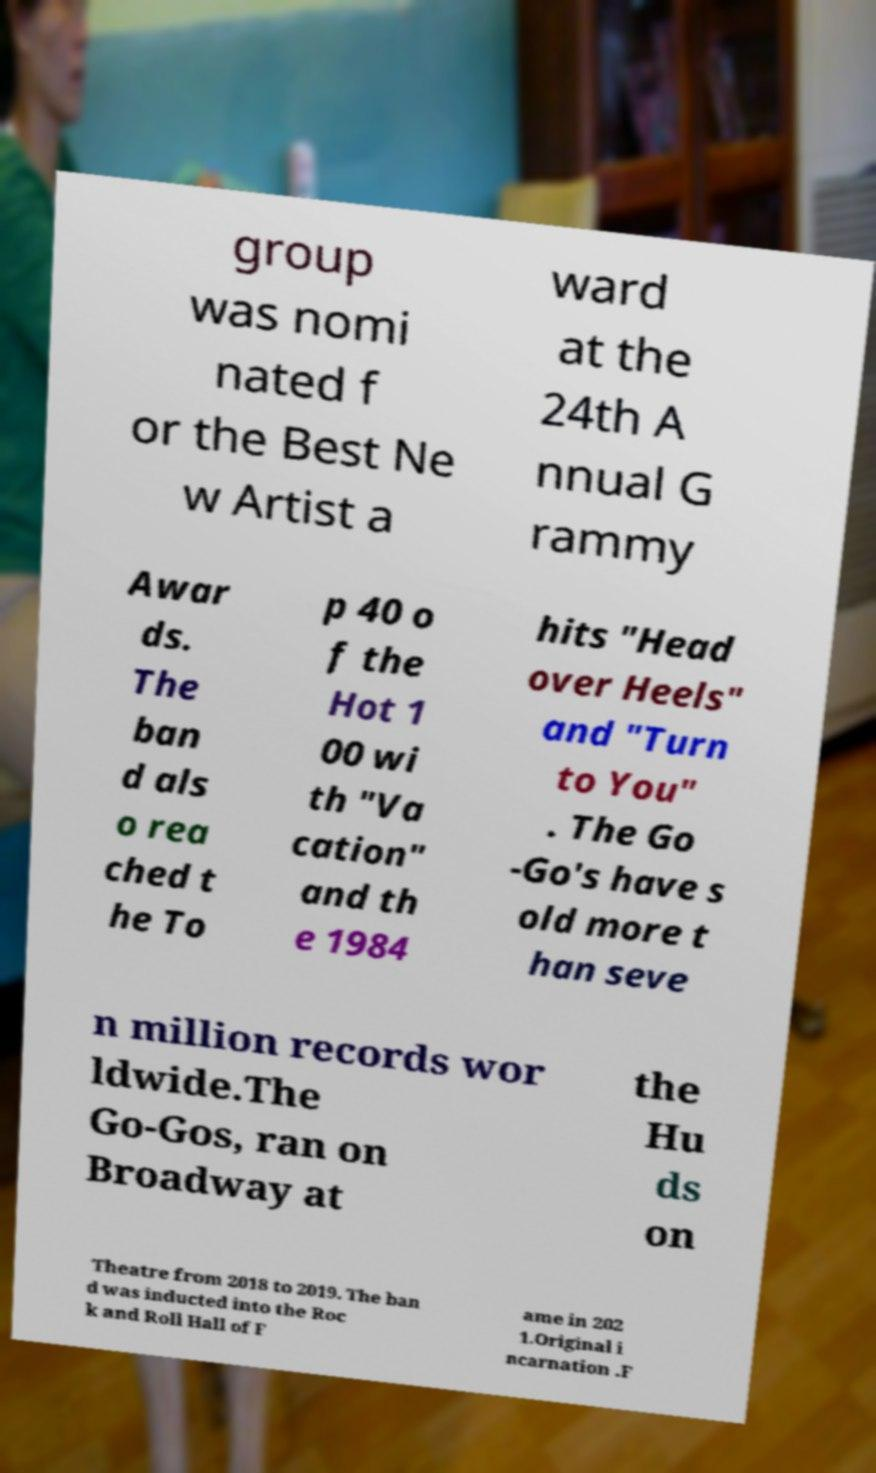For documentation purposes, I need the text within this image transcribed. Could you provide that? group was nomi nated f or the Best Ne w Artist a ward at the 24th A nnual G rammy Awar ds. The ban d als o rea ched t he To p 40 o f the Hot 1 00 wi th "Va cation" and th e 1984 hits "Head over Heels" and "Turn to You" . The Go -Go's have s old more t han seve n million records wor ldwide.The Go-Gos, ran on Broadway at the Hu ds on Theatre from 2018 to 2019. The ban d was inducted into the Roc k and Roll Hall of F ame in 202 1.Original i ncarnation .F 